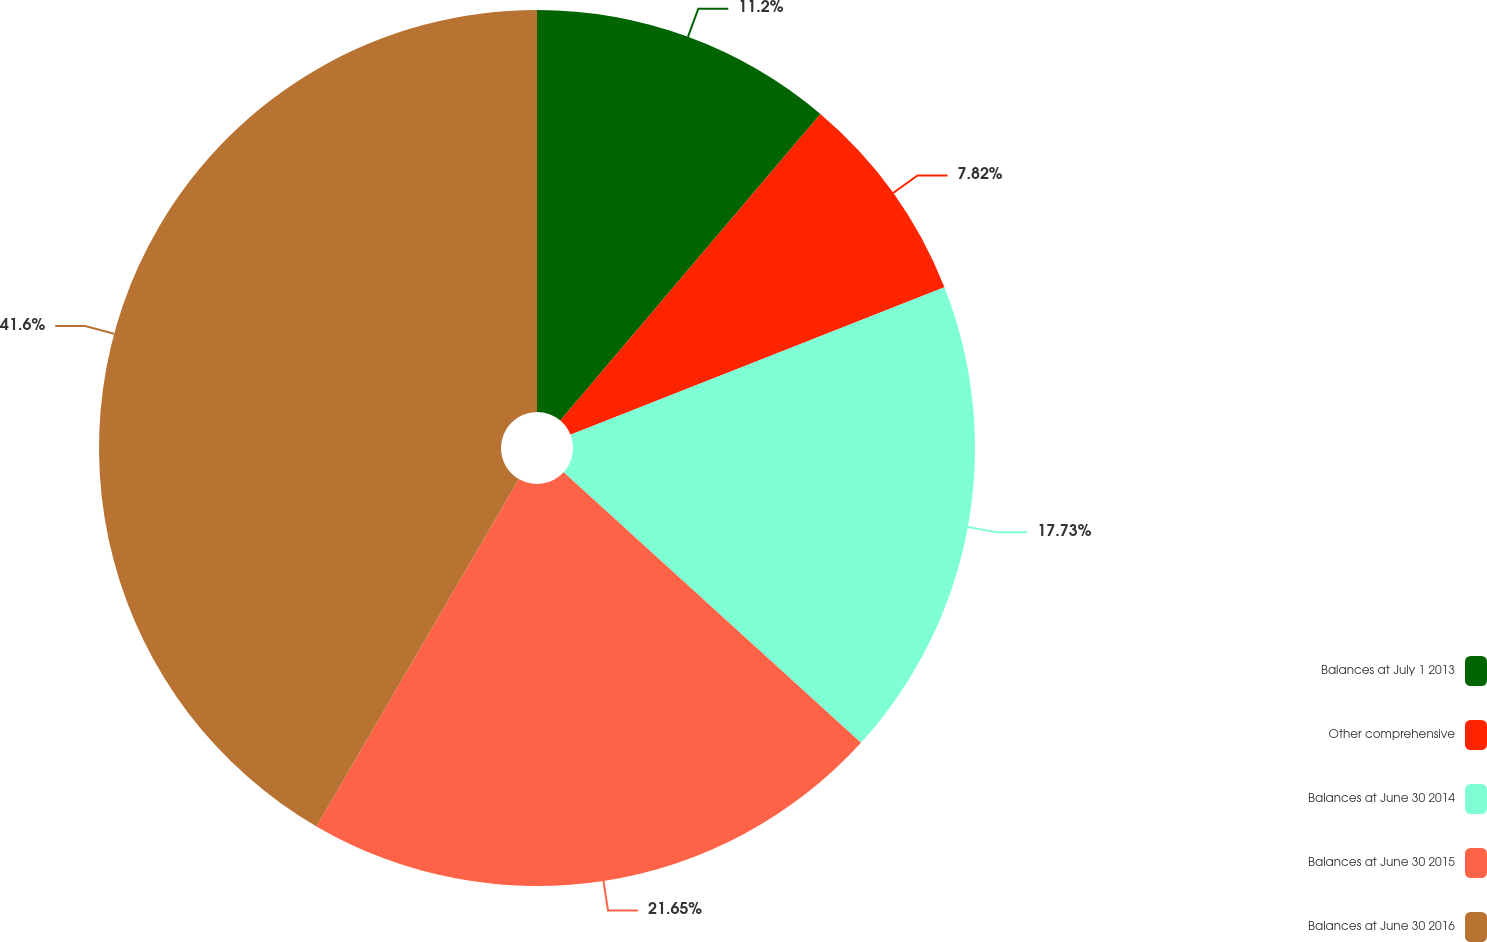Convert chart to OTSL. <chart><loc_0><loc_0><loc_500><loc_500><pie_chart><fcel>Balances at July 1 2013<fcel>Other comprehensive<fcel>Balances at June 30 2014<fcel>Balances at June 30 2015<fcel>Balances at June 30 2016<nl><fcel>11.2%<fcel>7.82%<fcel>17.73%<fcel>21.65%<fcel>41.6%<nl></chart> 